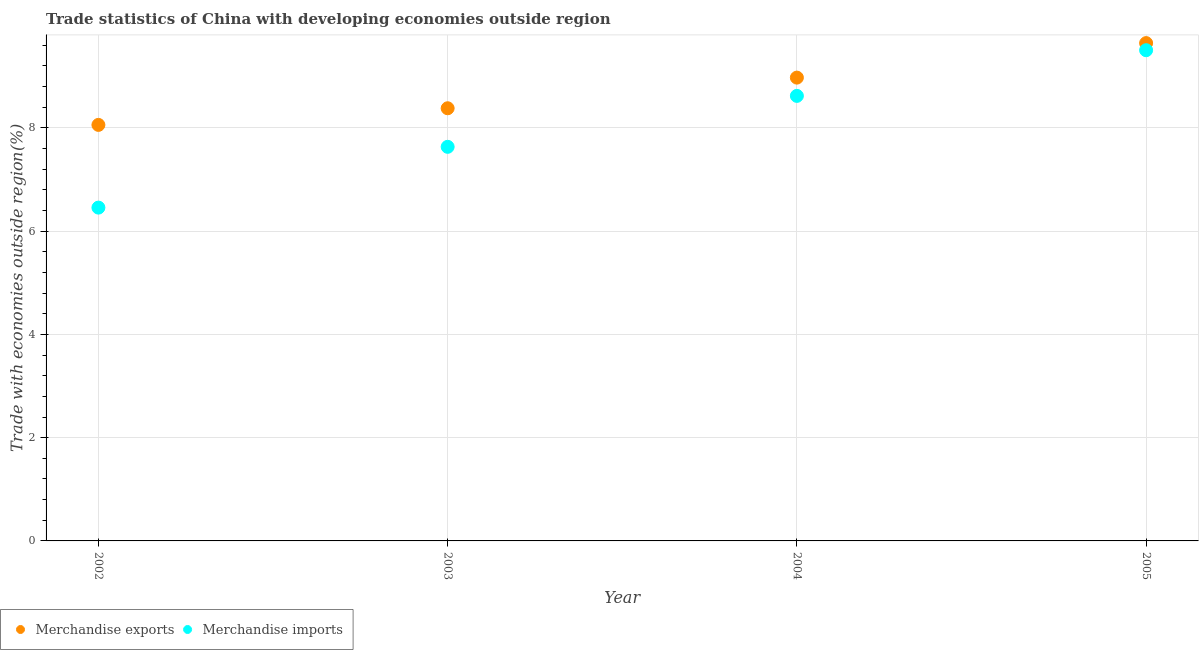What is the merchandise exports in 2004?
Ensure brevity in your answer.  8.97. Across all years, what is the maximum merchandise exports?
Keep it short and to the point. 9.64. Across all years, what is the minimum merchandise imports?
Your answer should be compact. 6.46. What is the total merchandise imports in the graph?
Offer a very short reply. 32.21. What is the difference between the merchandise exports in 2003 and that in 2004?
Offer a very short reply. -0.59. What is the difference between the merchandise imports in 2003 and the merchandise exports in 2002?
Your answer should be compact. -0.42. What is the average merchandise imports per year?
Make the answer very short. 8.05. In the year 2002, what is the difference between the merchandise exports and merchandise imports?
Provide a succinct answer. 1.6. In how many years, is the merchandise exports greater than 1.2000000000000002 %?
Offer a terse response. 4. What is the ratio of the merchandise exports in 2004 to that in 2005?
Provide a succinct answer. 0.93. Is the merchandise exports in 2002 less than that in 2005?
Your response must be concise. Yes. What is the difference between the highest and the second highest merchandise imports?
Offer a terse response. 0.88. What is the difference between the highest and the lowest merchandise imports?
Make the answer very short. 3.05. Is the sum of the merchandise exports in 2002 and 2004 greater than the maximum merchandise imports across all years?
Provide a short and direct response. Yes. Is the merchandise exports strictly greater than the merchandise imports over the years?
Your response must be concise. Yes. How many dotlines are there?
Ensure brevity in your answer.  2. How many years are there in the graph?
Ensure brevity in your answer.  4. Are the values on the major ticks of Y-axis written in scientific E-notation?
Keep it short and to the point. No. Does the graph contain grids?
Your response must be concise. Yes. How many legend labels are there?
Your answer should be compact. 2. What is the title of the graph?
Your answer should be very brief. Trade statistics of China with developing economies outside region. What is the label or title of the Y-axis?
Your answer should be very brief. Trade with economies outside region(%). What is the Trade with economies outside region(%) of Merchandise exports in 2002?
Provide a short and direct response. 8.06. What is the Trade with economies outside region(%) in Merchandise imports in 2002?
Your answer should be very brief. 6.46. What is the Trade with economies outside region(%) of Merchandise exports in 2003?
Your response must be concise. 8.38. What is the Trade with economies outside region(%) of Merchandise imports in 2003?
Provide a succinct answer. 7.63. What is the Trade with economies outside region(%) in Merchandise exports in 2004?
Provide a succinct answer. 8.97. What is the Trade with economies outside region(%) in Merchandise imports in 2004?
Offer a very short reply. 8.62. What is the Trade with economies outside region(%) of Merchandise exports in 2005?
Offer a very short reply. 9.64. What is the Trade with economies outside region(%) of Merchandise imports in 2005?
Offer a terse response. 9.5. Across all years, what is the maximum Trade with economies outside region(%) of Merchandise exports?
Offer a terse response. 9.64. Across all years, what is the maximum Trade with economies outside region(%) in Merchandise imports?
Keep it short and to the point. 9.5. Across all years, what is the minimum Trade with economies outside region(%) of Merchandise exports?
Your answer should be compact. 8.06. Across all years, what is the minimum Trade with economies outside region(%) in Merchandise imports?
Your answer should be very brief. 6.46. What is the total Trade with economies outside region(%) in Merchandise exports in the graph?
Your response must be concise. 35.05. What is the total Trade with economies outside region(%) of Merchandise imports in the graph?
Provide a short and direct response. 32.21. What is the difference between the Trade with economies outside region(%) of Merchandise exports in 2002 and that in 2003?
Make the answer very short. -0.32. What is the difference between the Trade with economies outside region(%) of Merchandise imports in 2002 and that in 2003?
Give a very brief answer. -1.18. What is the difference between the Trade with economies outside region(%) in Merchandise exports in 2002 and that in 2004?
Offer a terse response. -0.92. What is the difference between the Trade with economies outside region(%) of Merchandise imports in 2002 and that in 2004?
Offer a terse response. -2.16. What is the difference between the Trade with economies outside region(%) in Merchandise exports in 2002 and that in 2005?
Offer a terse response. -1.58. What is the difference between the Trade with economies outside region(%) in Merchandise imports in 2002 and that in 2005?
Provide a succinct answer. -3.05. What is the difference between the Trade with economies outside region(%) in Merchandise exports in 2003 and that in 2004?
Provide a short and direct response. -0.59. What is the difference between the Trade with economies outside region(%) of Merchandise imports in 2003 and that in 2004?
Keep it short and to the point. -0.99. What is the difference between the Trade with economies outside region(%) in Merchandise exports in 2003 and that in 2005?
Offer a terse response. -1.26. What is the difference between the Trade with economies outside region(%) in Merchandise imports in 2003 and that in 2005?
Make the answer very short. -1.87. What is the difference between the Trade with economies outside region(%) in Merchandise exports in 2004 and that in 2005?
Offer a very short reply. -0.67. What is the difference between the Trade with economies outside region(%) in Merchandise imports in 2004 and that in 2005?
Give a very brief answer. -0.88. What is the difference between the Trade with economies outside region(%) of Merchandise exports in 2002 and the Trade with economies outside region(%) of Merchandise imports in 2003?
Provide a short and direct response. 0.42. What is the difference between the Trade with economies outside region(%) in Merchandise exports in 2002 and the Trade with economies outside region(%) in Merchandise imports in 2004?
Provide a short and direct response. -0.56. What is the difference between the Trade with economies outside region(%) in Merchandise exports in 2002 and the Trade with economies outside region(%) in Merchandise imports in 2005?
Offer a very short reply. -1.45. What is the difference between the Trade with economies outside region(%) of Merchandise exports in 2003 and the Trade with economies outside region(%) of Merchandise imports in 2004?
Offer a very short reply. -0.24. What is the difference between the Trade with economies outside region(%) of Merchandise exports in 2003 and the Trade with economies outside region(%) of Merchandise imports in 2005?
Your answer should be compact. -1.12. What is the difference between the Trade with economies outside region(%) of Merchandise exports in 2004 and the Trade with economies outside region(%) of Merchandise imports in 2005?
Make the answer very short. -0.53. What is the average Trade with economies outside region(%) of Merchandise exports per year?
Your response must be concise. 8.76. What is the average Trade with economies outside region(%) of Merchandise imports per year?
Your answer should be compact. 8.05. In the year 2002, what is the difference between the Trade with economies outside region(%) of Merchandise exports and Trade with economies outside region(%) of Merchandise imports?
Ensure brevity in your answer.  1.6. In the year 2003, what is the difference between the Trade with economies outside region(%) in Merchandise exports and Trade with economies outside region(%) in Merchandise imports?
Ensure brevity in your answer.  0.75. In the year 2004, what is the difference between the Trade with economies outside region(%) of Merchandise exports and Trade with economies outside region(%) of Merchandise imports?
Your answer should be very brief. 0.35. In the year 2005, what is the difference between the Trade with economies outside region(%) in Merchandise exports and Trade with economies outside region(%) in Merchandise imports?
Give a very brief answer. 0.14. What is the ratio of the Trade with economies outside region(%) of Merchandise exports in 2002 to that in 2003?
Make the answer very short. 0.96. What is the ratio of the Trade with economies outside region(%) in Merchandise imports in 2002 to that in 2003?
Make the answer very short. 0.85. What is the ratio of the Trade with economies outside region(%) in Merchandise exports in 2002 to that in 2004?
Offer a very short reply. 0.9. What is the ratio of the Trade with economies outside region(%) in Merchandise imports in 2002 to that in 2004?
Offer a terse response. 0.75. What is the ratio of the Trade with economies outside region(%) in Merchandise exports in 2002 to that in 2005?
Your response must be concise. 0.84. What is the ratio of the Trade with economies outside region(%) in Merchandise imports in 2002 to that in 2005?
Offer a terse response. 0.68. What is the ratio of the Trade with economies outside region(%) of Merchandise exports in 2003 to that in 2004?
Make the answer very short. 0.93. What is the ratio of the Trade with economies outside region(%) of Merchandise imports in 2003 to that in 2004?
Offer a very short reply. 0.89. What is the ratio of the Trade with economies outside region(%) in Merchandise exports in 2003 to that in 2005?
Give a very brief answer. 0.87. What is the ratio of the Trade with economies outside region(%) of Merchandise imports in 2003 to that in 2005?
Provide a succinct answer. 0.8. What is the ratio of the Trade with economies outside region(%) of Merchandise exports in 2004 to that in 2005?
Your answer should be compact. 0.93. What is the ratio of the Trade with economies outside region(%) in Merchandise imports in 2004 to that in 2005?
Ensure brevity in your answer.  0.91. What is the difference between the highest and the second highest Trade with economies outside region(%) of Merchandise exports?
Offer a terse response. 0.67. What is the difference between the highest and the second highest Trade with economies outside region(%) in Merchandise imports?
Keep it short and to the point. 0.88. What is the difference between the highest and the lowest Trade with economies outside region(%) of Merchandise exports?
Your response must be concise. 1.58. What is the difference between the highest and the lowest Trade with economies outside region(%) of Merchandise imports?
Give a very brief answer. 3.05. 